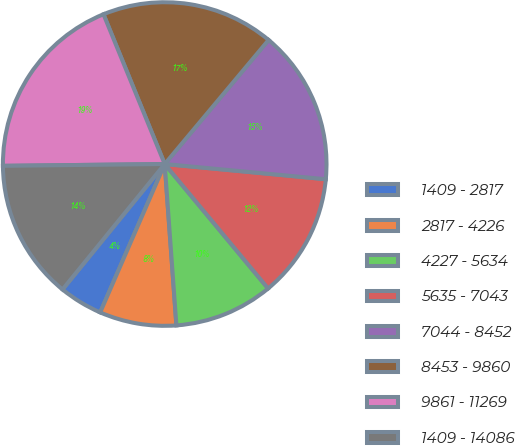<chart> <loc_0><loc_0><loc_500><loc_500><pie_chart><fcel>1409 - 2817<fcel>2817 - 4226<fcel>4227 - 5634<fcel>5635 - 7043<fcel>7044 - 8452<fcel>8453 - 9860<fcel>9861 - 11269<fcel>1409 - 14086<nl><fcel>4.35%<fcel>7.68%<fcel>9.88%<fcel>12.47%<fcel>15.4%<fcel>17.27%<fcel>19.0%<fcel>13.94%<nl></chart> 